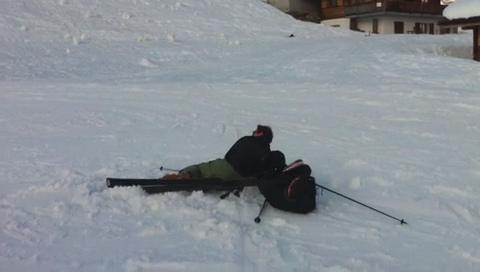Where could he go to get warm?
Answer briefly. Inside. What are the people doing?
Give a very brief answer. Skiing. Is there snow on the ground?
Keep it brief. Yes. 